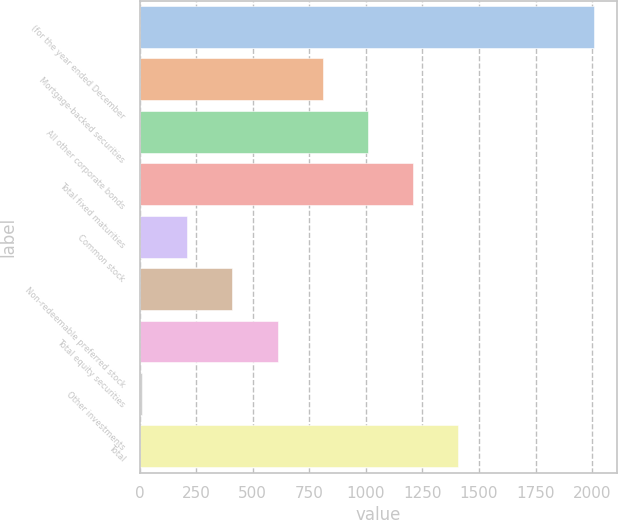Convert chart. <chart><loc_0><loc_0><loc_500><loc_500><bar_chart><fcel>(for the year ended December<fcel>Mortgage-backed securities<fcel>All other corporate bonds<fcel>Total fixed maturities<fcel>Common stock<fcel>Non-redeemable preferred stock<fcel>Total equity securities<fcel>Other investments<fcel>Total<nl><fcel>2009<fcel>809.6<fcel>1009.5<fcel>1209.4<fcel>209.9<fcel>409.8<fcel>609.7<fcel>10<fcel>1409.3<nl></chart> 